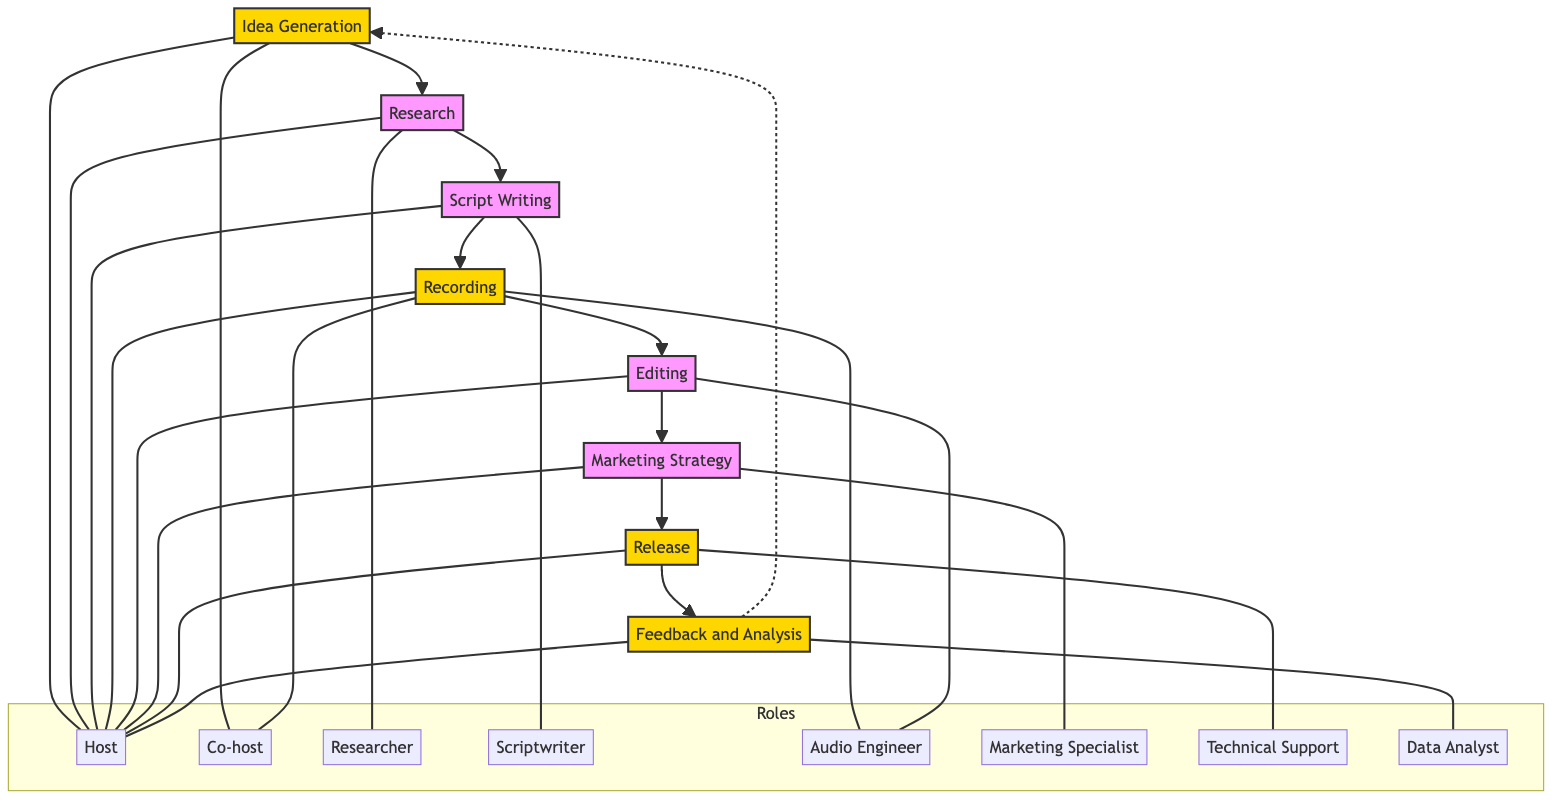What is the first step in the workflow? The first step in the workflow, as indicated in the diagram, is "Idea Generation". This is the starting point of the process before moving to research and subsequent steps.
Answer: Idea Generation How many total steps are there in the workflow? By counting the nodes listed in the diagram, there are a total of eight steps: Idea Generation, Research, Script Writing, Recording, Editing, Marketing Strategy, Release, and Feedback and Analysis.
Answer: 8 Which roles are involved in the "Recording" step? The "Recording" step involves the roles of Host, Co-host, and Audio Engineer, as shown by the connections from the "Recording" node to these roles in the diagram.
Answer: Host, Co-host, Audio Engineer What is the last step before "Feedback and Analysis"? The last step before "Feedback and Analysis" is "Release". This flow can be traced from the "Release" node directly to the "Feedback and Analysis" node which follows it.
Answer: Release Which step connects back to "Idea Generation"? The "Feedback and Analysis" step has a dashed line connecting back to "Idea Generation", indicating that feedback from the listeners leads to new ideas for future episodes.
Answer: Feedback and Analysis How many roles are directly involved in the "Research" step? There are two roles involved in the "Research" step, namely the Researcher and the Host, as indicated by the connections from the Research node to these roles.
Answer: 2 Name one step that involves the Marketing Specialist. The step that involves the Marketing Specialist is "Marketing Strategy". This is derived directly from the connections shown in the diagram.
Answer: Marketing Strategy What signifies the roles of the Host throughout the diagram? The Host is connected to multiple steps in the diagram, including Idea Generation, Research, Script Writing, Recording, Marketing Strategy, Release, and Feedback and Analysis, indicating their involvement in a majority of the steps.
Answer: Host 